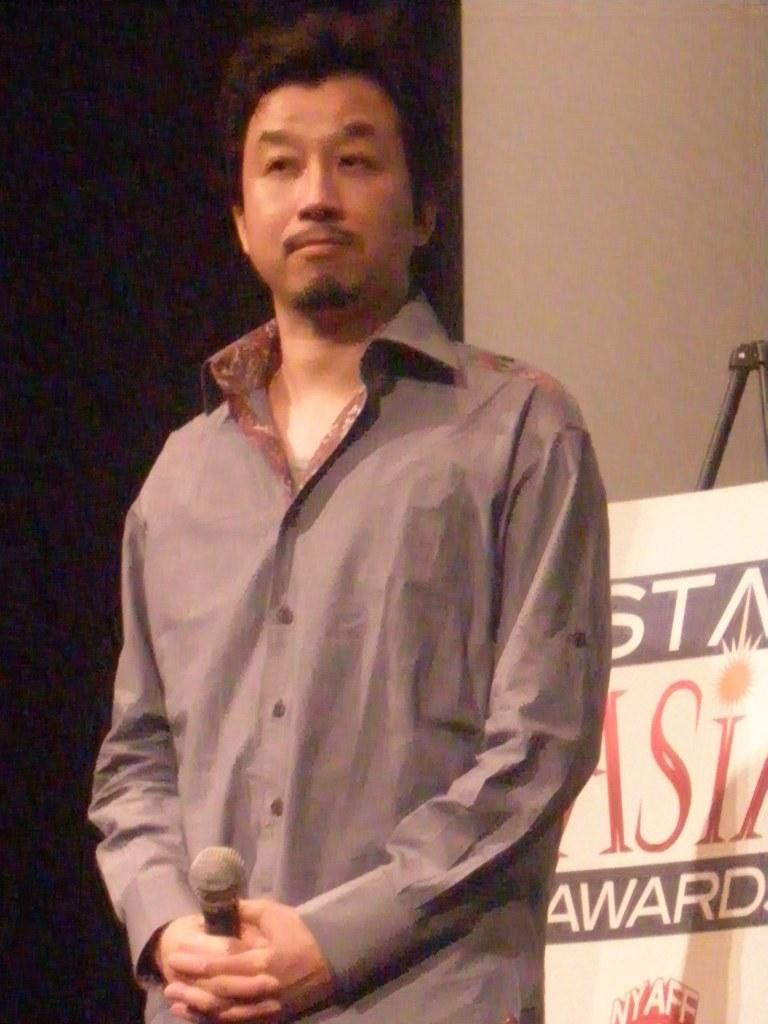What is the person in the image doing? The person is standing in the image and holding a microphone. What can be seen on the left side of the image? There is a black color background on the left side of the image. What is present in the background of the image? There is a wall in the image. What is on the right side of the image? There is a board on the right side of the image. What type of bells can be heard ringing in the image? There are no bells present in the image, and therefore no sound can be heard. Is the person in the image preparing a stew? There is no indication in the image that the person is preparing a stew or any other type of food. 